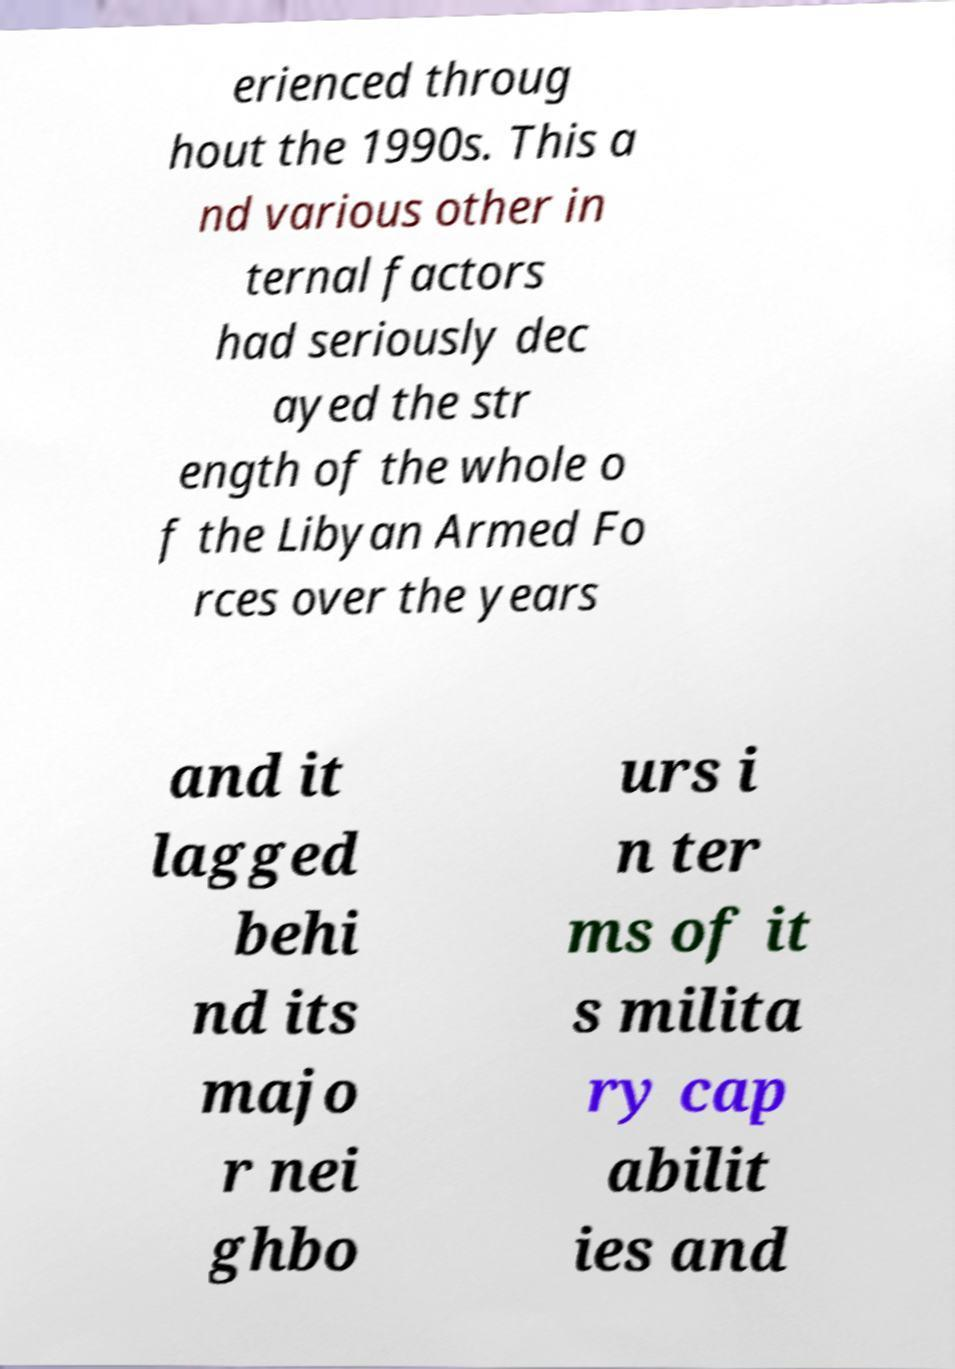For documentation purposes, I need the text within this image transcribed. Could you provide that? erienced throug hout the 1990s. This a nd various other in ternal factors had seriously dec ayed the str ength of the whole o f the Libyan Armed Fo rces over the years and it lagged behi nd its majo r nei ghbo urs i n ter ms of it s milita ry cap abilit ies and 